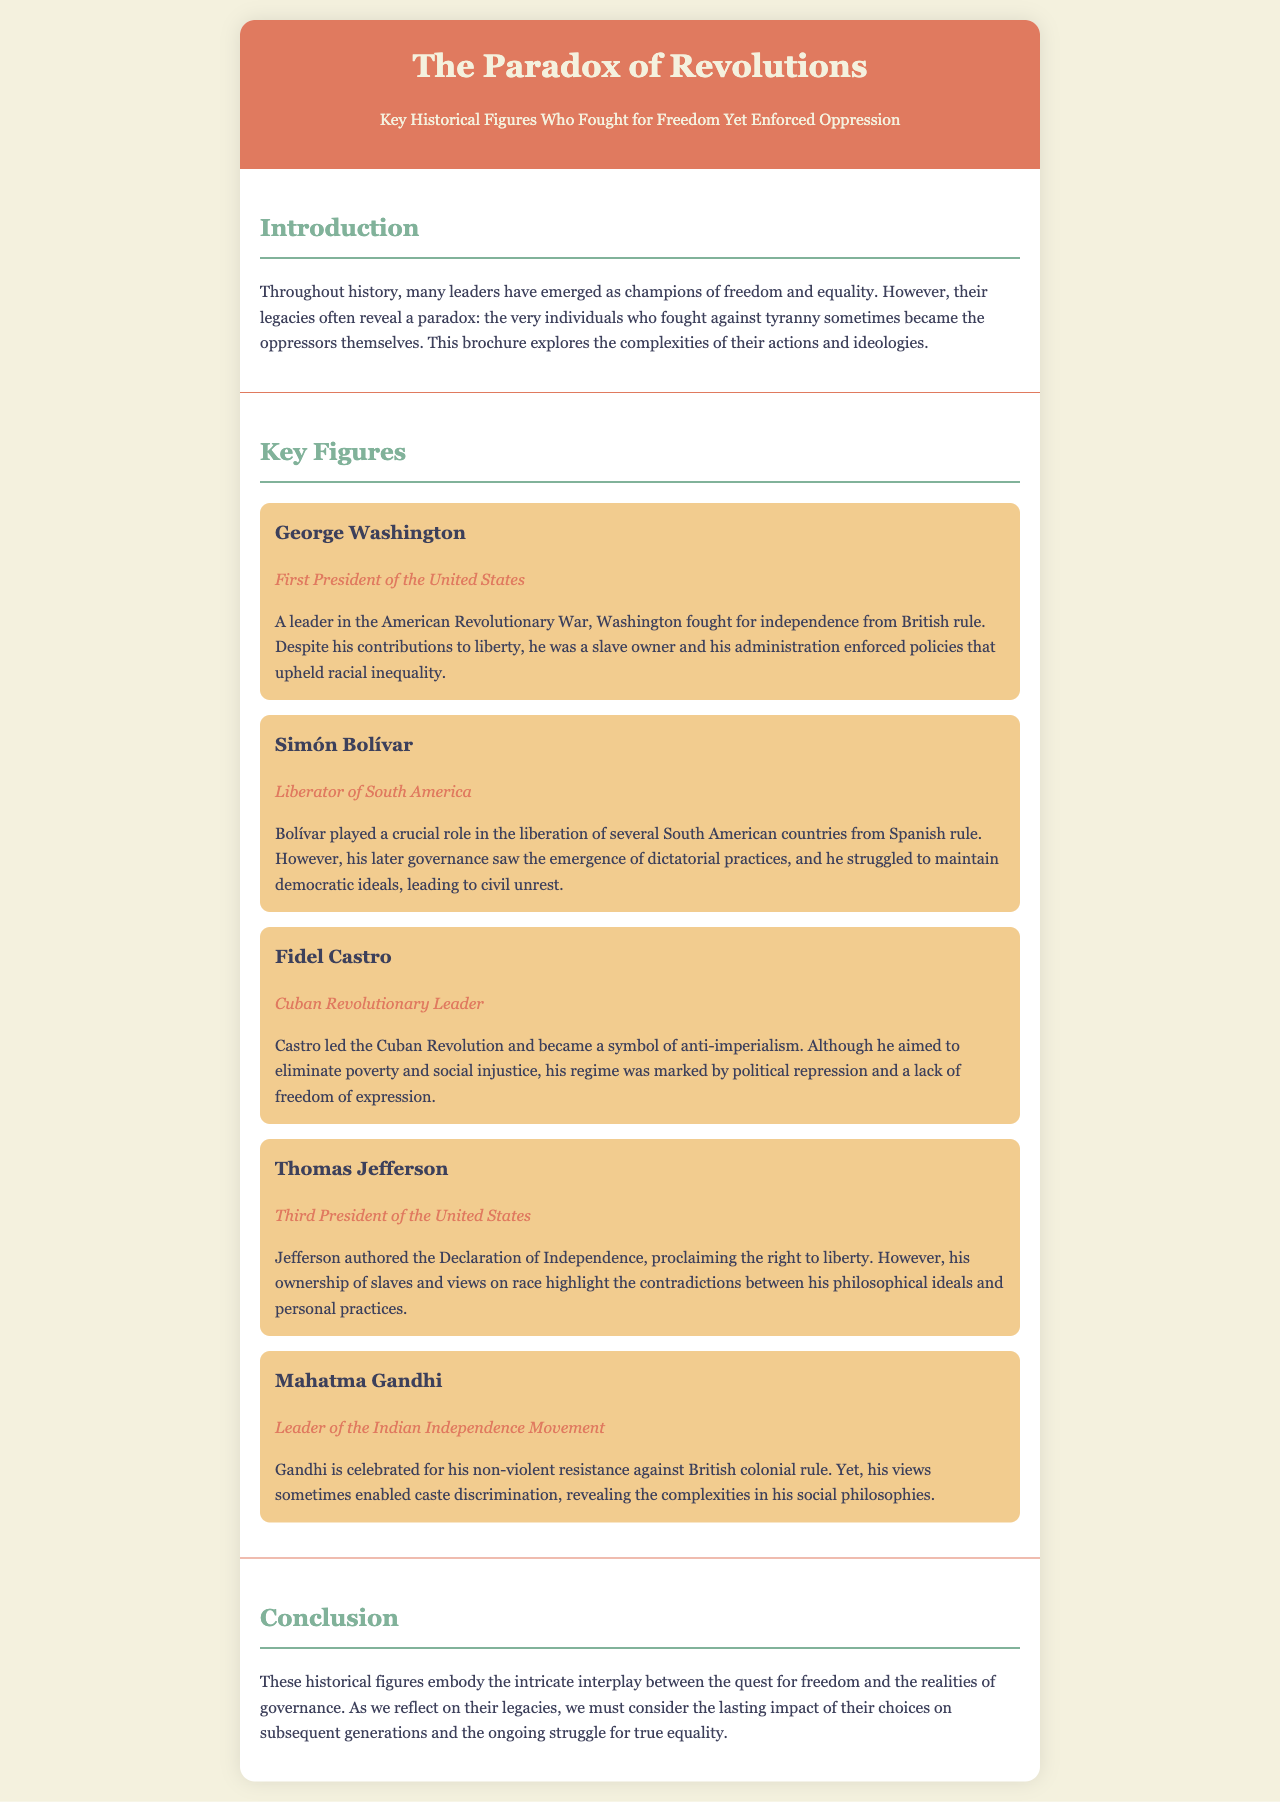What is the title of the brochure? The title is prominently displayed in the header section of the document.
Answer: The Paradox of Revolutions Who is the leader of the Indian Independence Movement mentioned in the document? The section on key figures lists leaders and their roles, including Gandhi’s title.
Answer: Mahatma Gandhi What role did George Washington hold? The role of George Washington is specified below his name in the document.
Answer: First President of the United States Which historical figure fought against British colonial rule? The document mentions several key figures, specifically noting their impacts against British rule.
Answer: Mahatma Gandhi What did Simón Bolívar struggle to maintain? The text indicates Bolívar's challenges in governance and ideals, specifically mentioning a particular struggle.
Answer: Democratic ideals How did Fidel Castro's regime affect freedom of expression? The brochure states how Castro's regime was marked by certain practices that impacted freedom.
Answer: Political repression Which US president authored the Declaration of Independence? The answer is found within his section as part of his contributions mentioned.
Answer: Thomas Jefferson What major contradiction is associated with Thomas Jefferson? The document discusses contradictions related to his philosophical ideals and personal practices.
Answer: Ownership of slaves 